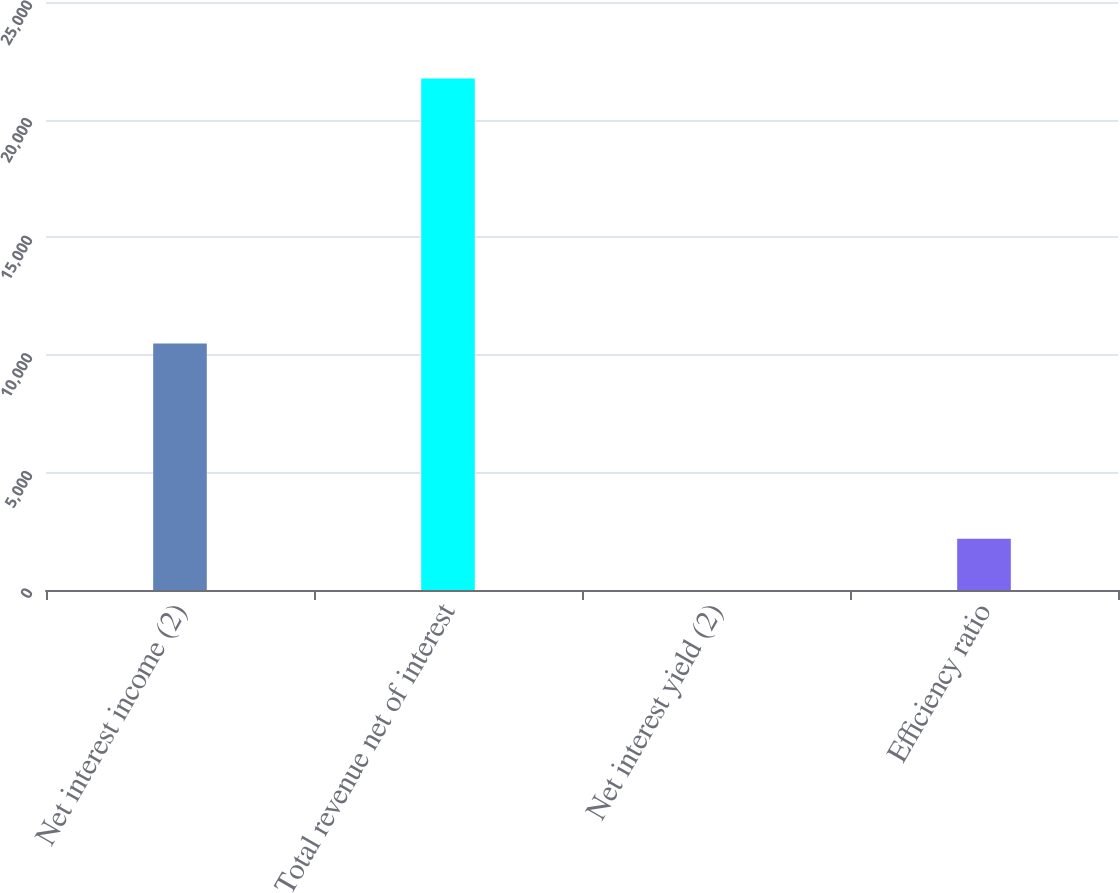Convert chart. <chart><loc_0><loc_0><loc_500><loc_500><bar_chart><fcel>Net interest income (2)<fcel>Total revenue net of interest<fcel>Net interest yield (2)<fcel>Efficiency ratio<nl><fcel>10479<fcel>21743<fcel>2.33<fcel>2176.4<nl></chart> 